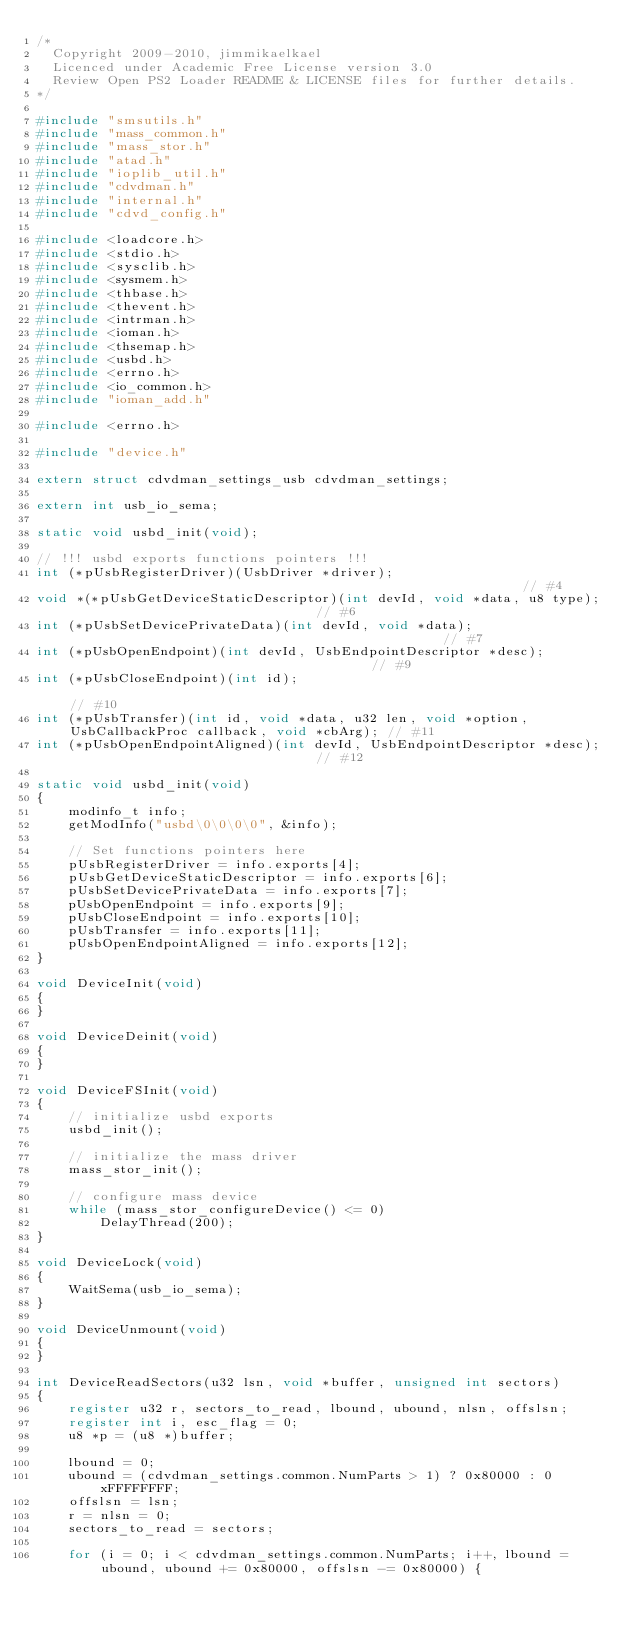<code> <loc_0><loc_0><loc_500><loc_500><_C_>/*
  Copyright 2009-2010, jimmikaelkael
  Licenced under Academic Free License version 3.0
  Review Open PS2 Loader README & LICENSE files for further details.
*/

#include "smsutils.h"
#include "mass_common.h"
#include "mass_stor.h"
#include "atad.h"
#include "ioplib_util.h"
#include "cdvdman.h"
#include "internal.h"
#include "cdvd_config.h"

#include <loadcore.h>
#include <stdio.h>
#include <sysclib.h>
#include <sysmem.h>
#include <thbase.h>
#include <thevent.h>
#include <intrman.h>
#include <ioman.h>
#include <thsemap.h>
#include <usbd.h>
#include <errno.h>
#include <io_common.h>
#include "ioman_add.h"

#include <errno.h>

#include "device.h"

extern struct cdvdman_settings_usb cdvdman_settings;

extern int usb_io_sema;

static void usbd_init(void);

// !!! usbd exports functions pointers !!!
int (*pUsbRegisterDriver)(UsbDriver *driver);                                                          // #4
void *(*pUsbGetDeviceStaticDescriptor)(int devId, void *data, u8 type);                                // #6
int (*pUsbSetDevicePrivateData)(int devId, void *data);                                                // #7
int (*pUsbOpenEndpoint)(int devId, UsbEndpointDescriptor *desc);                                       // #9
int (*pUsbCloseEndpoint)(int id);                                                                      // #10
int (*pUsbTransfer)(int id, void *data, u32 len, void *option, UsbCallbackProc callback, void *cbArg); // #11
int (*pUsbOpenEndpointAligned)(int devId, UsbEndpointDescriptor *desc);                                // #12

static void usbd_init(void)
{
    modinfo_t info;
    getModInfo("usbd\0\0\0\0", &info);

    // Set functions pointers here
    pUsbRegisterDriver = info.exports[4];
    pUsbGetDeviceStaticDescriptor = info.exports[6];
    pUsbSetDevicePrivateData = info.exports[7];
    pUsbOpenEndpoint = info.exports[9];
    pUsbCloseEndpoint = info.exports[10];
    pUsbTransfer = info.exports[11];
    pUsbOpenEndpointAligned = info.exports[12];
}

void DeviceInit(void)
{
}

void DeviceDeinit(void)
{
}

void DeviceFSInit(void)
{
    // initialize usbd exports
    usbd_init();

    // initialize the mass driver
    mass_stor_init();

    // configure mass device
    while (mass_stor_configureDevice() <= 0)
        DelayThread(200);
}

void DeviceLock(void)
{
    WaitSema(usb_io_sema);
}

void DeviceUnmount(void)
{
}

int DeviceReadSectors(u32 lsn, void *buffer, unsigned int sectors)
{
    register u32 r, sectors_to_read, lbound, ubound, nlsn, offslsn;
    register int i, esc_flag = 0;
    u8 *p = (u8 *)buffer;

    lbound = 0;
    ubound = (cdvdman_settings.common.NumParts > 1) ? 0x80000 : 0xFFFFFFFF;
    offslsn = lsn;
    r = nlsn = 0;
    sectors_to_read = sectors;

    for (i = 0; i < cdvdman_settings.common.NumParts; i++, lbound = ubound, ubound += 0x80000, offslsn -= 0x80000) {
</code> 